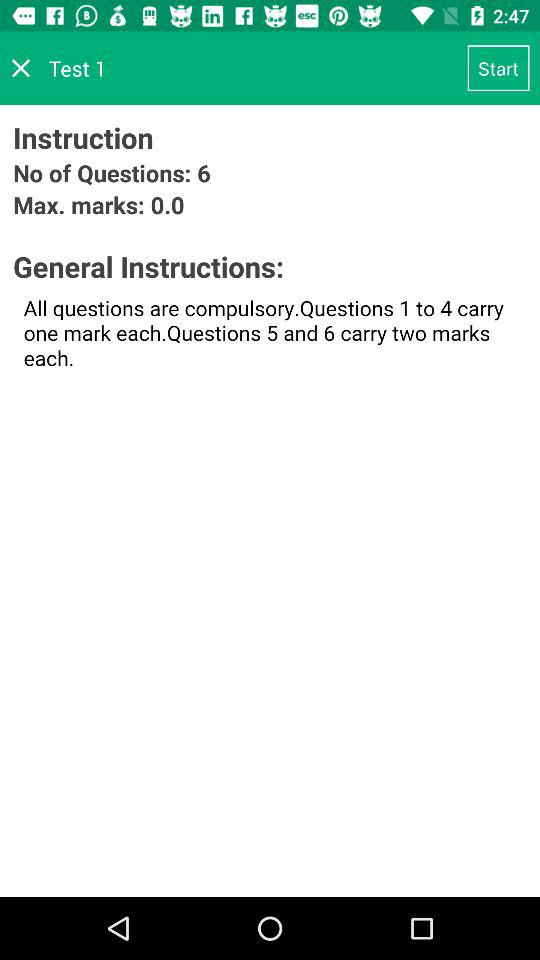What is the test name? The test name is "Test 1". 